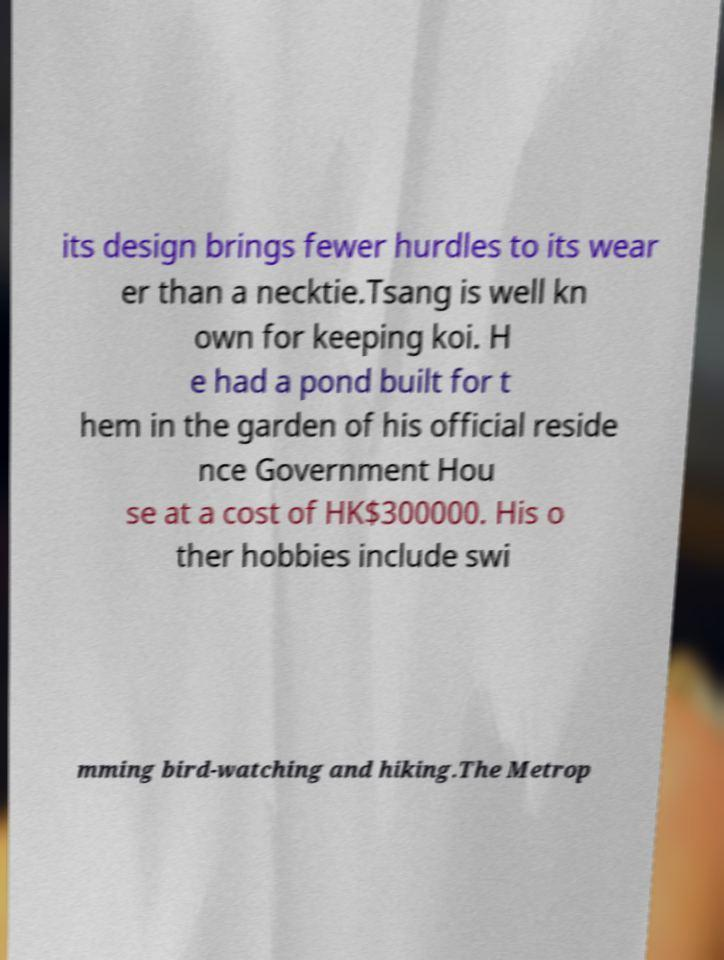Please read and relay the text visible in this image. What does it say? its design brings fewer hurdles to its wear er than a necktie.Tsang is well kn own for keeping koi. H e had a pond built for t hem in the garden of his official reside nce Government Hou se at a cost of HK$300000. His o ther hobbies include swi mming bird-watching and hiking.The Metrop 